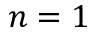Convert formula to latex. <formula><loc_0><loc_0><loc_500><loc_500>n = 1</formula> 